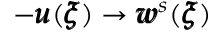<formula> <loc_0><loc_0><loc_500><loc_500>- { \pm b u } ( { \pm b \xi } ) \rightarrow { \pm b w } ^ { s } ( { \pm b \xi } )</formula> 